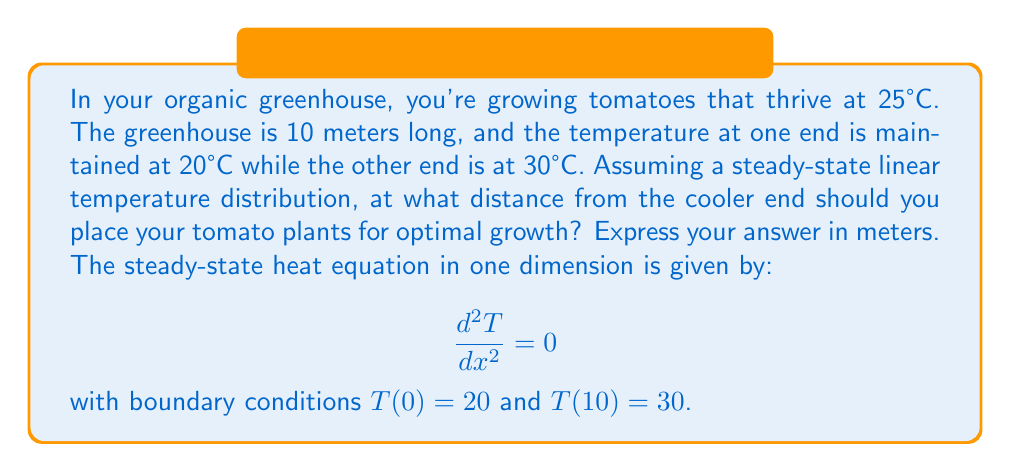Teach me how to tackle this problem. Let's approach this step-by-step:

1) The general solution to the steady-state heat equation is a linear function:
   
   $T(x) = ax + b$

2) Using the boundary conditions:
   At $x = 0$: $T(0) = b = 20$
   At $x = 10$: $T(10) = 10a + 20 = 30$

3) Solving for $a$:
   $10a = 10$
   $a = 1$

4) Therefore, the temperature distribution is:
   
   $T(x) = x + 20$

5) We want to find $x$ where $T(x) = 25°C$:
   
   $25 = x + 20$
   $x = 5$

This means the optimal temperature of 25°C occurs 5 meters from the cooler end.
Answer: 5 meters 